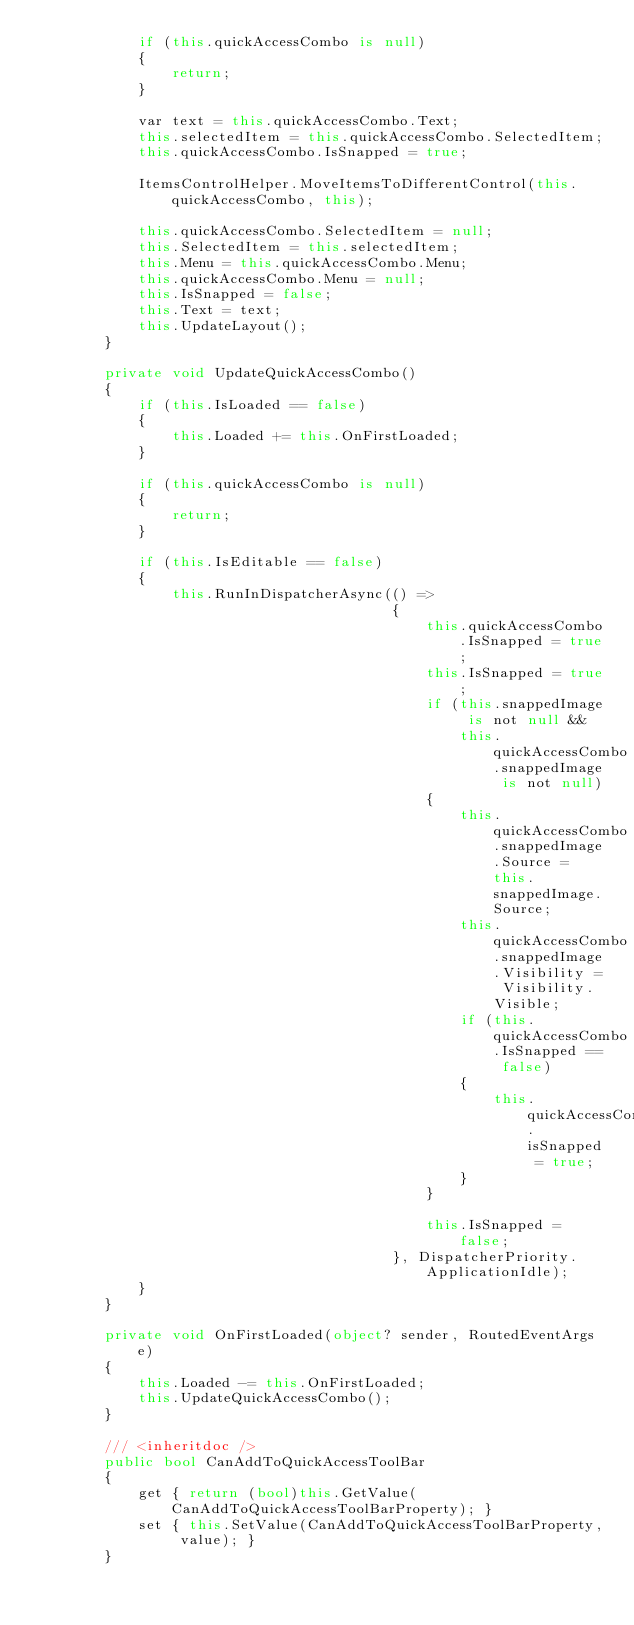Convert code to text. <code><loc_0><loc_0><loc_500><loc_500><_C#_>            if (this.quickAccessCombo is null)
            {
                return;
            }

            var text = this.quickAccessCombo.Text;
            this.selectedItem = this.quickAccessCombo.SelectedItem;
            this.quickAccessCombo.IsSnapped = true;

            ItemsControlHelper.MoveItemsToDifferentControl(this.quickAccessCombo, this);

            this.quickAccessCombo.SelectedItem = null;
            this.SelectedItem = this.selectedItem;
            this.Menu = this.quickAccessCombo.Menu;
            this.quickAccessCombo.Menu = null;
            this.IsSnapped = false;
            this.Text = text;
            this.UpdateLayout();
        }

        private void UpdateQuickAccessCombo()
        {
            if (this.IsLoaded == false)
            {
                this.Loaded += this.OnFirstLoaded;
            }

            if (this.quickAccessCombo is null)
            {
                return;
            }

            if (this.IsEditable == false)
            {
                this.RunInDispatcherAsync(() =>
                                          {
                                              this.quickAccessCombo.IsSnapped = true;
                                              this.IsSnapped = true;
                                              if (this.snappedImage is not null &&
                                                  this.quickAccessCombo.snappedImage is not null)
                                              {
                                                  this.quickAccessCombo.snappedImage.Source = this.snappedImage.Source;
                                                  this.quickAccessCombo.snappedImage.Visibility = Visibility.Visible;
                                                  if (this.quickAccessCombo.IsSnapped == false)
                                                  {
                                                      this.quickAccessCombo.isSnapped = true;
                                                  }
                                              }

                                              this.IsSnapped = false;
                                          }, DispatcherPriority.ApplicationIdle);
            }
        }

        private void OnFirstLoaded(object? sender, RoutedEventArgs e)
        {
            this.Loaded -= this.OnFirstLoaded;
            this.UpdateQuickAccessCombo();
        }

        /// <inheritdoc />
        public bool CanAddToQuickAccessToolBar
        {
            get { return (bool)this.GetValue(CanAddToQuickAccessToolBarProperty); }
            set { this.SetValue(CanAddToQuickAccessToolBarProperty, value); }
        }
</code> 